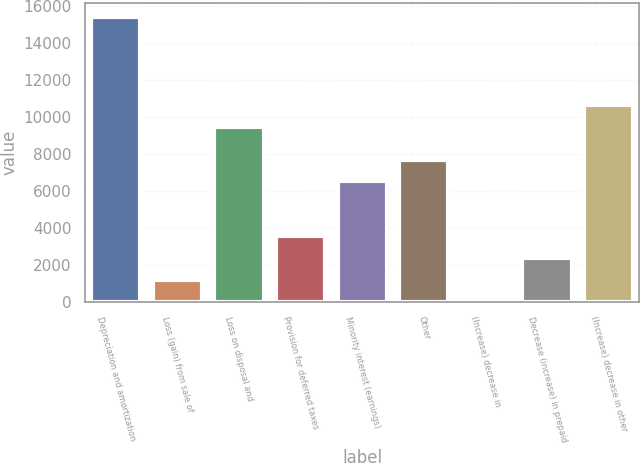<chart> <loc_0><loc_0><loc_500><loc_500><bar_chart><fcel>Depreciation and amortization<fcel>Loss (gain) from sale of<fcel>Loss on disposal and<fcel>Provision for deferred taxes<fcel>Minority interest (earnings)<fcel>Other<fcel>(Increase) decrease in<fcel>Decrease (increase) in prepaid<fcel>(Increase) decrease in other<nl><fcel>15415<fcel>1195<fcel>9490<fcel>3565<fcel>6527.5<fcel>7712.5<fcel>10<fcel>2380<fcel>10675<nl></chart> 